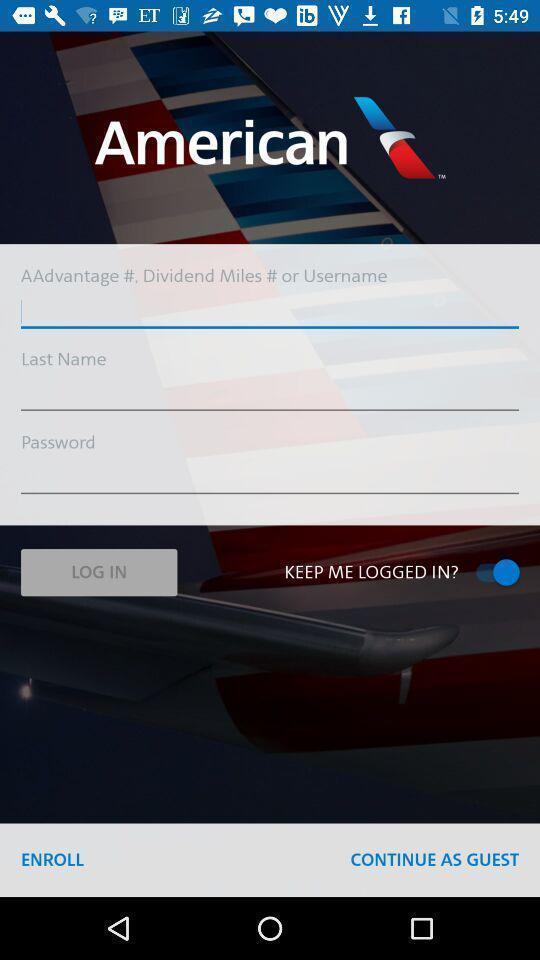Describe the visual elements of this screenshot. Welcome page showing login details in an airlines related app. 